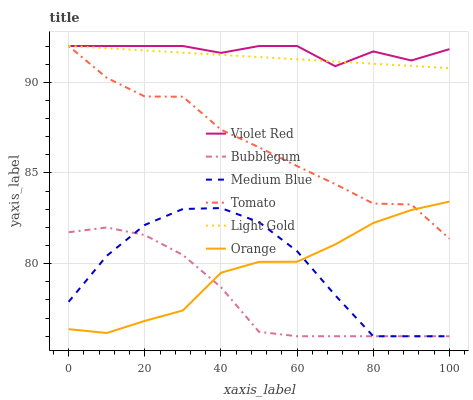Does Bubblegum have the minimum area under the curve?
Answer yes or no. Yes. Does Violet Red have the maximum area under the curve?
Answer yes or no. Yes. Does Medium Blue have the minimum area under the curve?
Answer yes or no. No. Does Medium Blue have the maximum area under the curve?
Answer yes or no. No. Is Light Gold the smoothest?
Answer yes or no. Yes. Is Tomato the roughest?
Answer yes or no. Yes. Is Violet Red the smoothest?
Answer yes or no. No. Is Violet Red the roughest?
Answer yes or no. No. Does Medium Blue have the lowest value?
Answer yes or no. Yes. Does Violet Red have the lowest value?
Answer yes or no. No. Does Light Gold have the highest value?
Answer yes or no. Yes. Does Medium Blue have the highest value?
Answer yes or no. No. Is Orange less than Violet Red?
Answer yes or no. Yes. Is Light Gold greater than Bubblegum?
Answer yes or no. Yes. Does Tomato intersect Violet Red?
Answer yes or no. Yes. Is Tomato less than Violet Red?
Answer yes or no. No. Is Tomato greater than Violet Red?
Answer yes or no. No. Does Orange intersect Violet Red?
Answer yes or no. No. 